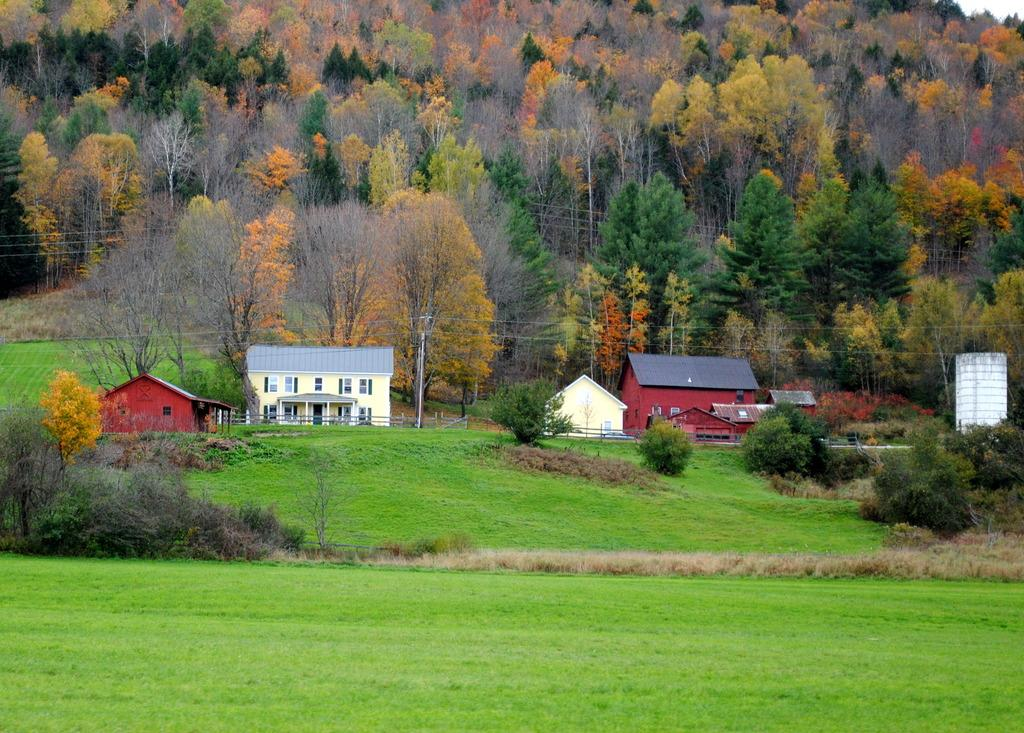What type of vegetation is at the bottom of the image? There is grass at the bottom of the image. What can be seen in the background of the image? There are houses and trees in the background of the image. What is located in the middle of the image? There is a pole in the middle of the image. What is connected to the pole in the middle of the image? There are wires associated with the pole in the middle of the image. Where is the key used to unlock the school in the image? There is no school or key present in the image. How does the grass sleep in the image? Grass does not sleep; it is a plant and does not have the ability to sleep. 